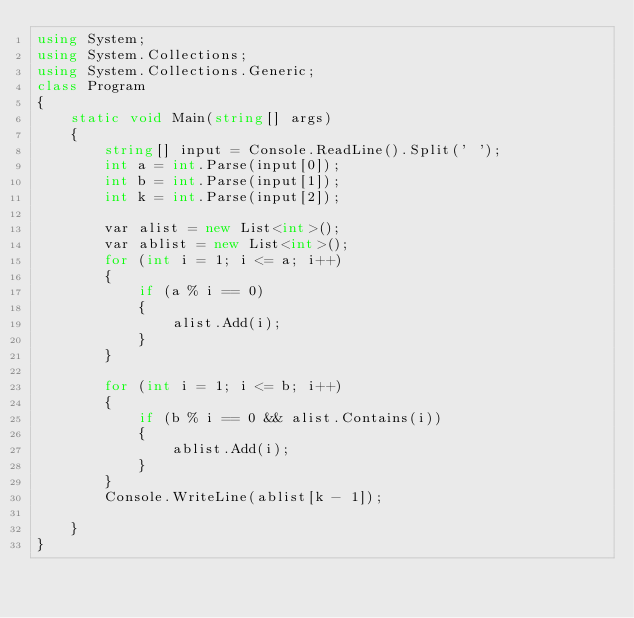<code> <loc_0><loc_0><loc_500><loc_500><_C#_>using System;
using System.Collections;
using System.Collections.Generic;
class Program
{
    static void Main(string[] args)
    {
        string[] input = Console.ReadLine().Split(' ');
        int a = int.Parse(input[0]);
        int b = int.Parse(input[1]);
        int k = int.Parse(input[2]);

        var alist = new List<int>();
        var ablist = new List<int>();
        for (int i = 1; i <= a; i++)
        {
            if (a % i == 0)
            {
                alist.Add(i);
            }
        }

        for (int i = 1; i <= b; i++)
        {
            if (b % i == 0 && alist.Contains(i))
            {
                ablist.Add(i);
            }
        }
        Console.WriteLine(ablist[k - 1]);

    }
}</code> 